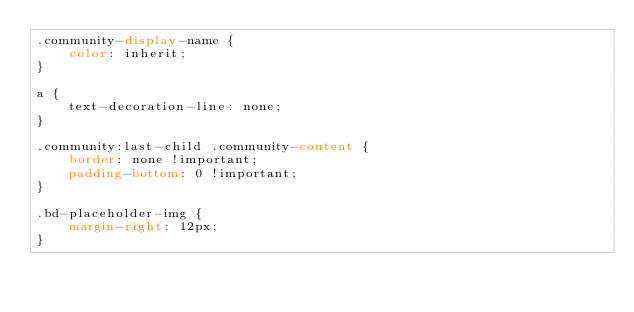Convert code to text. <code><loc_0><loc_0><loc_500><loc_500><_CSS_>.community-display-name {
    color: inherit;
}

a {
    text-decoration-line: none;
}

.community:last-child .community-content {
    border: none !important;
    padding-bottom: 0 !important;
}

.bd-placeholder-img {
    margin-right: 12px;
}</code> 